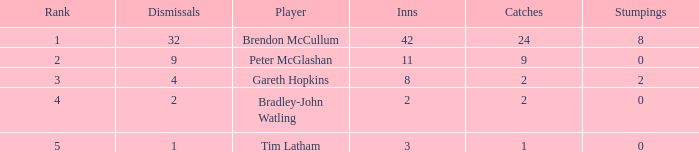List the ranks of all dismissals with a value of 4 3.0. 